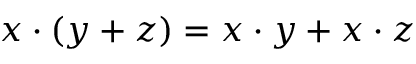Convert formula to latex. <formula><loc_0><loc_0><loc_500><loc_500>x \cdot ( y + z ) = x \cdot y + x \cdot z</formula> 